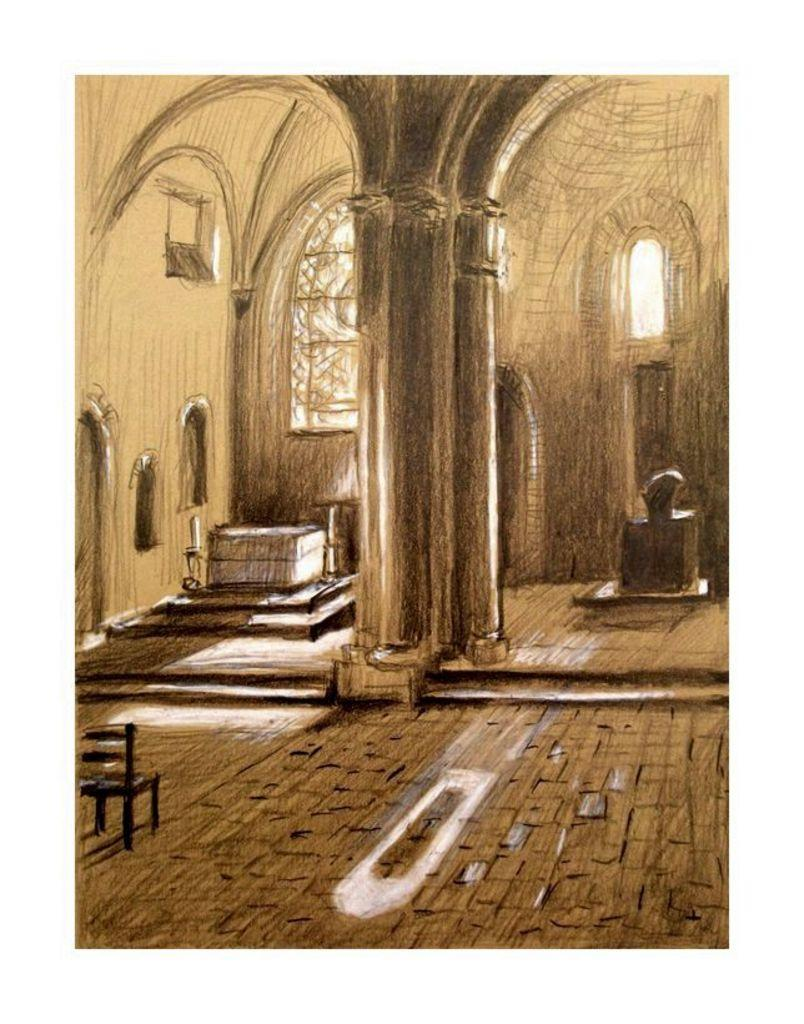What type of artwork is the image? The image is a painting. What is the setting of the painting? The painting depicts an inside view of a building. What architectural features can be seen in the building? There are windows and pillars in the building. What type of furniture is present in the building? There is a chair in the building. How does the painting compare to a wave in the ocean? The painting and a wave in the ocean are not comparable, as they are two different subjects and cannot be compared directly. 